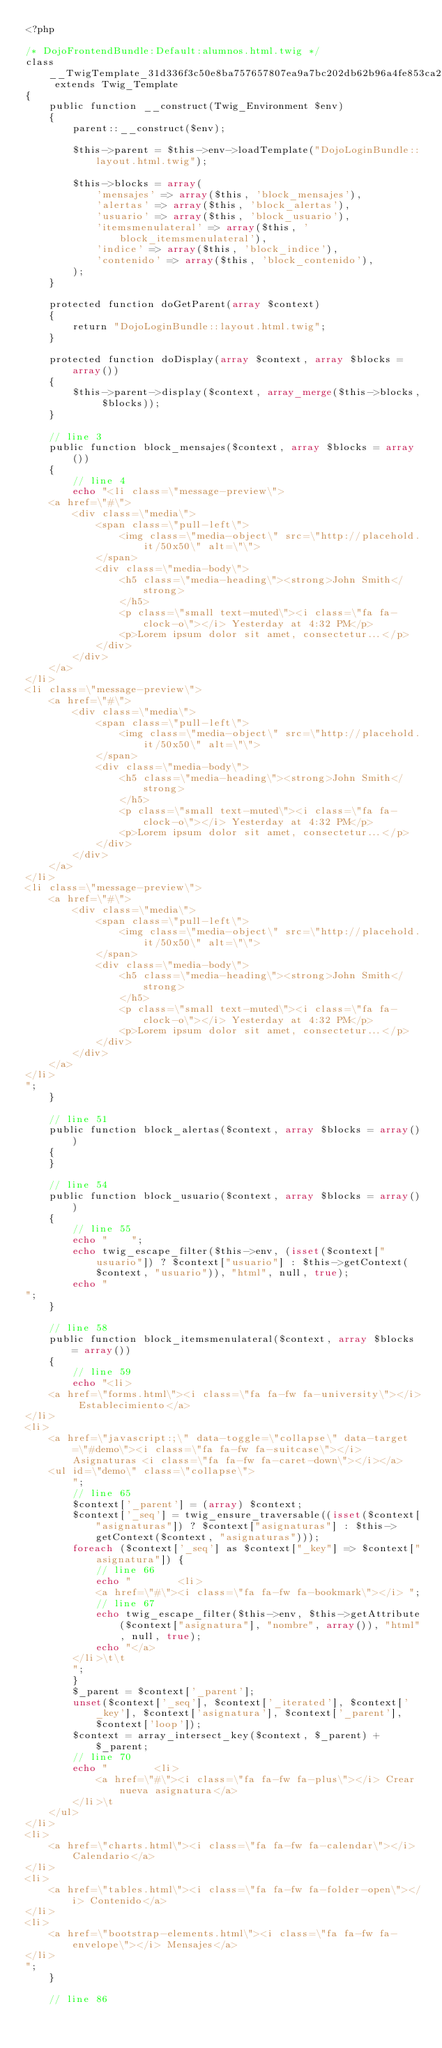Convert code to text. <code><loc_0><loc_0><loc_500><loc_500><_PHP_><?php

/* DojoFrontendBundle:Default:alumnos.html.twig */
class __TwigTemplate_31d336f3c50e8ba757657807ea9a7bc202db62b96a4fe853ca2ad57949f7420f extends Twig_Template
{
    public function __construct(Twig_Environment $env)
    {
        parent::__construct($env);

        $this->parent = $this->env->loadTemplate("DojoLoginBundle::layout.html.twig");

        $this->blocks = array(
            'mensajes' => array($this, 'block_mensajes'),
            'alertas' => array($this, 'block_alertas'),
            'usuario' => array($this, 'block_usuario'),
            'itemsmenulateral' => array($this, 'block_itemsmenulateral'),
            'indice' => array($this, 'block_indice'),
            'contenido' => array($this, 'block_contenido'),
        );
    }

    protected function doGetParent(array $context)
    {
        return "DojoLoginBundle::layout.html.twig";
    }

    protected function doDisplay(array $context, array $blocks = array())
    {
        $this->parent->display($context, array_merge($this->blocks, $blocks));
    }

    // line 3
    public function block_mensajes($context, array $blocks = array())
    {
        // line 4
        echo "<li class=\"message-preview\">
    <a href=\"#\">
        <div class=\"media\">
            <span class=\"pull-left\">
                <img class=\"media-object\" src=\"http://placehold.it/50x50\" alt=\"\">
            </span>
            <div class=\"media-body\">
                <h5 class=\"media-heading\"><strong>John Smith</strong>
                </h5>
                <p class=\"small text-muted\"><i class=\"fa fa-clock-o\"></i> Yesterday at 4:32 PM</p>
                <p>Lorem ipsum dolor sit amet, consectetur...</p>
            </div>
        </div>
    </a>
</li>
<li class=\"message-preview\">
    <a href=\"#\">
        <div class=\"media\">
            <span class=\"pull-left\">
                <img class=\"media-object\" src=\"http://placehold.it/50x50\" alt=\"\">
            </span>
            <div class=\"media-body\">
                <h5 class=\"media-heading\"><strong>John Smith</strong>
                </h5>
                <p class=\"small text-muted\"><i class=\"fa fa-clock-o\"></i> Yesterday at 4:32 PM</p>
                <p>Lorem ipsum dolor sit amet, consectetur...</p>
            </div>
        </div>
    </a>
</li>
<li class=\"message-preview\">
    <a href=\"#\">
        <div class=\"media\">
            <span class=\"pull-left\">
                <img class=\"media-object\" src=\"http://placehold.it/50x50\" alt=\"\">
            </span>
            <div class=\"media-body\">
                <h5 class=\"media-heading\"><strong>John Smith</strong>
                </h5>
                <p class=\"small text-muted\"><i class=\"fa fa-clock-o\"></i> Yesterday at 4:32 PM</p>
                <p>Lorem ipsum dolor sit amet, consectetur...</p>
            </div>
        </div>
    </a>
</li>
";
    }

    // line 51
    public function block_alertas($context, array $blocks = array())
    {
    }

    // line 54
    public function block_usuario($context, array $blocks = array())
    {
        // line 55
        echo "    ";
        echo twig_escape_filter($this->env, (isset($context["usuario"]) ? $context["usuario"] : $this->getContext($context, "usuario")), "html", null, true);
        echo "
";
    }

    // line 58
    public function block_itemsmenulateral($context, array $blocks = array())
    {
        // line 59
        echo "<li>
    <a href=\"forms.html\"><i class=\"fa fa-fw fa-university\"></i> Establecimiento</a>
</li>
<li>
    <a href=\"javascript:;\" data-toggle=\"collapse\" data-target=\"#demo\"><i class=\"fa fa-fw fa-suitcase\"></i> Asignaturas <i class=\"fa fa-fw fa-caret-down\"></i></a>
    <ul id=\"demo\" class=\"collapse\">
        ";
        // line 65
        $context['_parent'] = (array) $context;
        $context['_seq'] = twig_ensure_traversable((isset($context["asignaturas"]) ? $context["asignaturas"] : $this->getContext($context, "asignaturas")));
        foreach ($context['_seq'] as $context["_key"] => $context["asignatura"]) {
            // line 66
            echo "        <li>
            <a href=\"#\"><i class=\"fa fa-fw fa-bookmark\"></i> ";
            // line 67
            echo twig_escape_filter($this->env, $this->getAttribute($context["asignatura"], "nombre", array()), "html", null, true);
            echo "</a>
        </li>\t\t
        ";
        }
        $_parent = $context['_parent'];
        unset($context['_seq'], $context['_iterated'], $context['_key'], $context['asignatura'], $context['_parent'], $context['loop']);
        $context = array_intersect_key($context, $_parent) + $_parent;
        // line 70
        echo "        <li>
            <a href=\"#\"><i class=\"fa fa-fw fa-plus\"></i> Crear nueva asignatura</a>
        </li>\t
    </ul>
</li>
<li>
    <a href=\"charts.html\"><i class=\"fa fa-fw fa-calendar\"></i> Calendario</a>
</li>
<li>
    <a href=\"tables.html\"><i class=\"fa fa-fw fa-folder-open\"></i> Contenido</a>
</li>
<li>
    <a href=\"bootstrap-elements.html\"><i class=\"fa fa-fw fa-envelope\"></i> Mensajes</a>
</li>    
";
    }

    // line 86</code> 